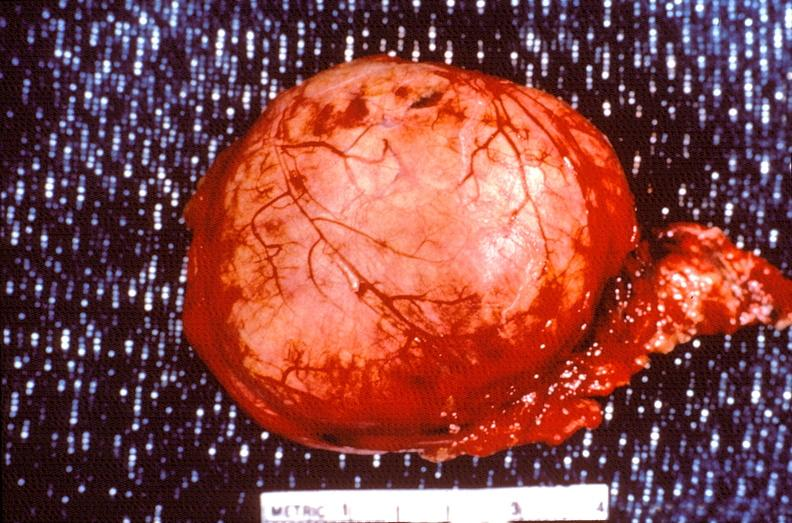s an opened peritoneal cavity cause by fibrous band strangulation present?
Answer the question using a single word or phrase. No 